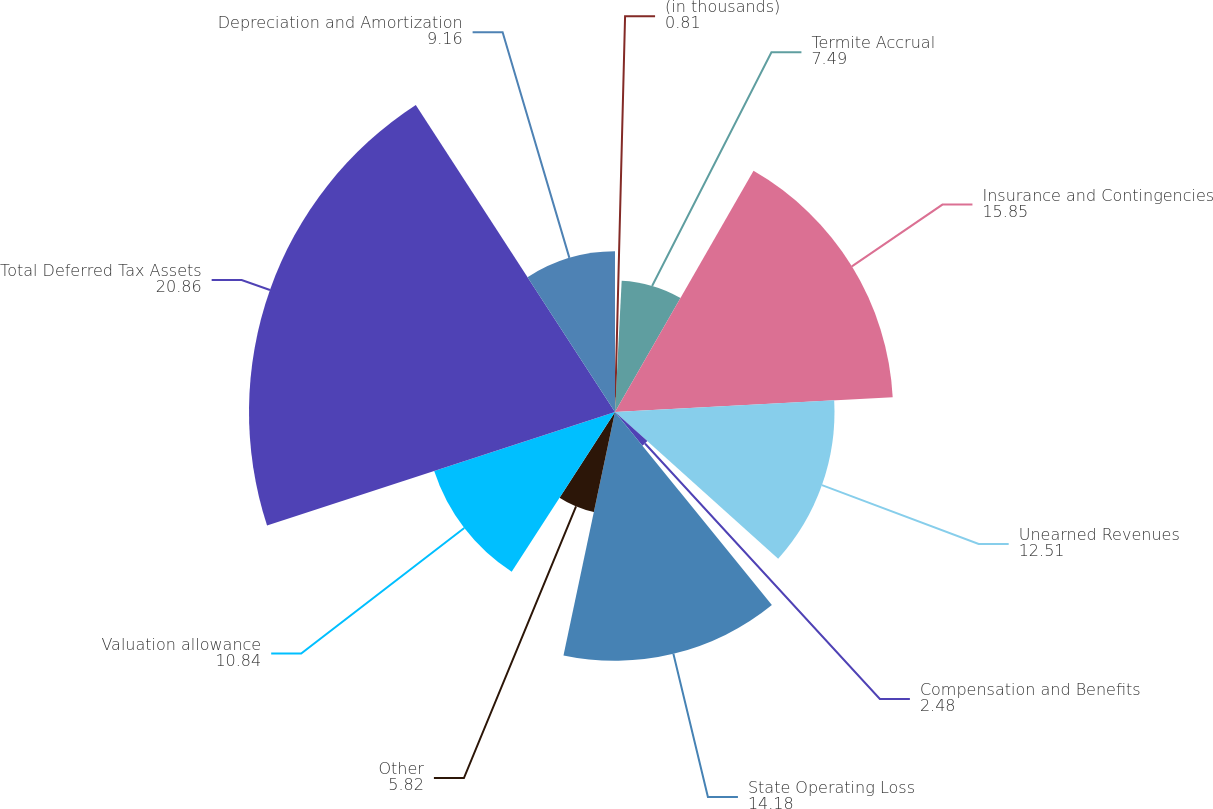Convert chart to OTSL. <chart><loc_0><loc_0><loc_500><loc_500><pie_chart><fcel>(in thousands)<fcel>Termite Accrual<fcel>Insurance and Contingencies<fcel>Unearned Revenues<fcel>Compensation and Benefits<fcel>State Operating Loss<fcel>Other<fcel>Valuation allowance<fcel>Total Deferred Tax Assets<fcel>Depreciation and Amortization<nl><fcel>0.81%<fcel>7.49%<fcel>15.85%<fcel>12.51%<fcel>2.48%<fcel>14.18%<fcel>5.82%<fcel>10.84%<fcel>20.86%<fcel>9.16%<nl></chart> 